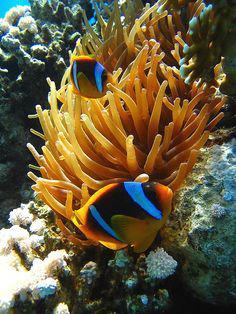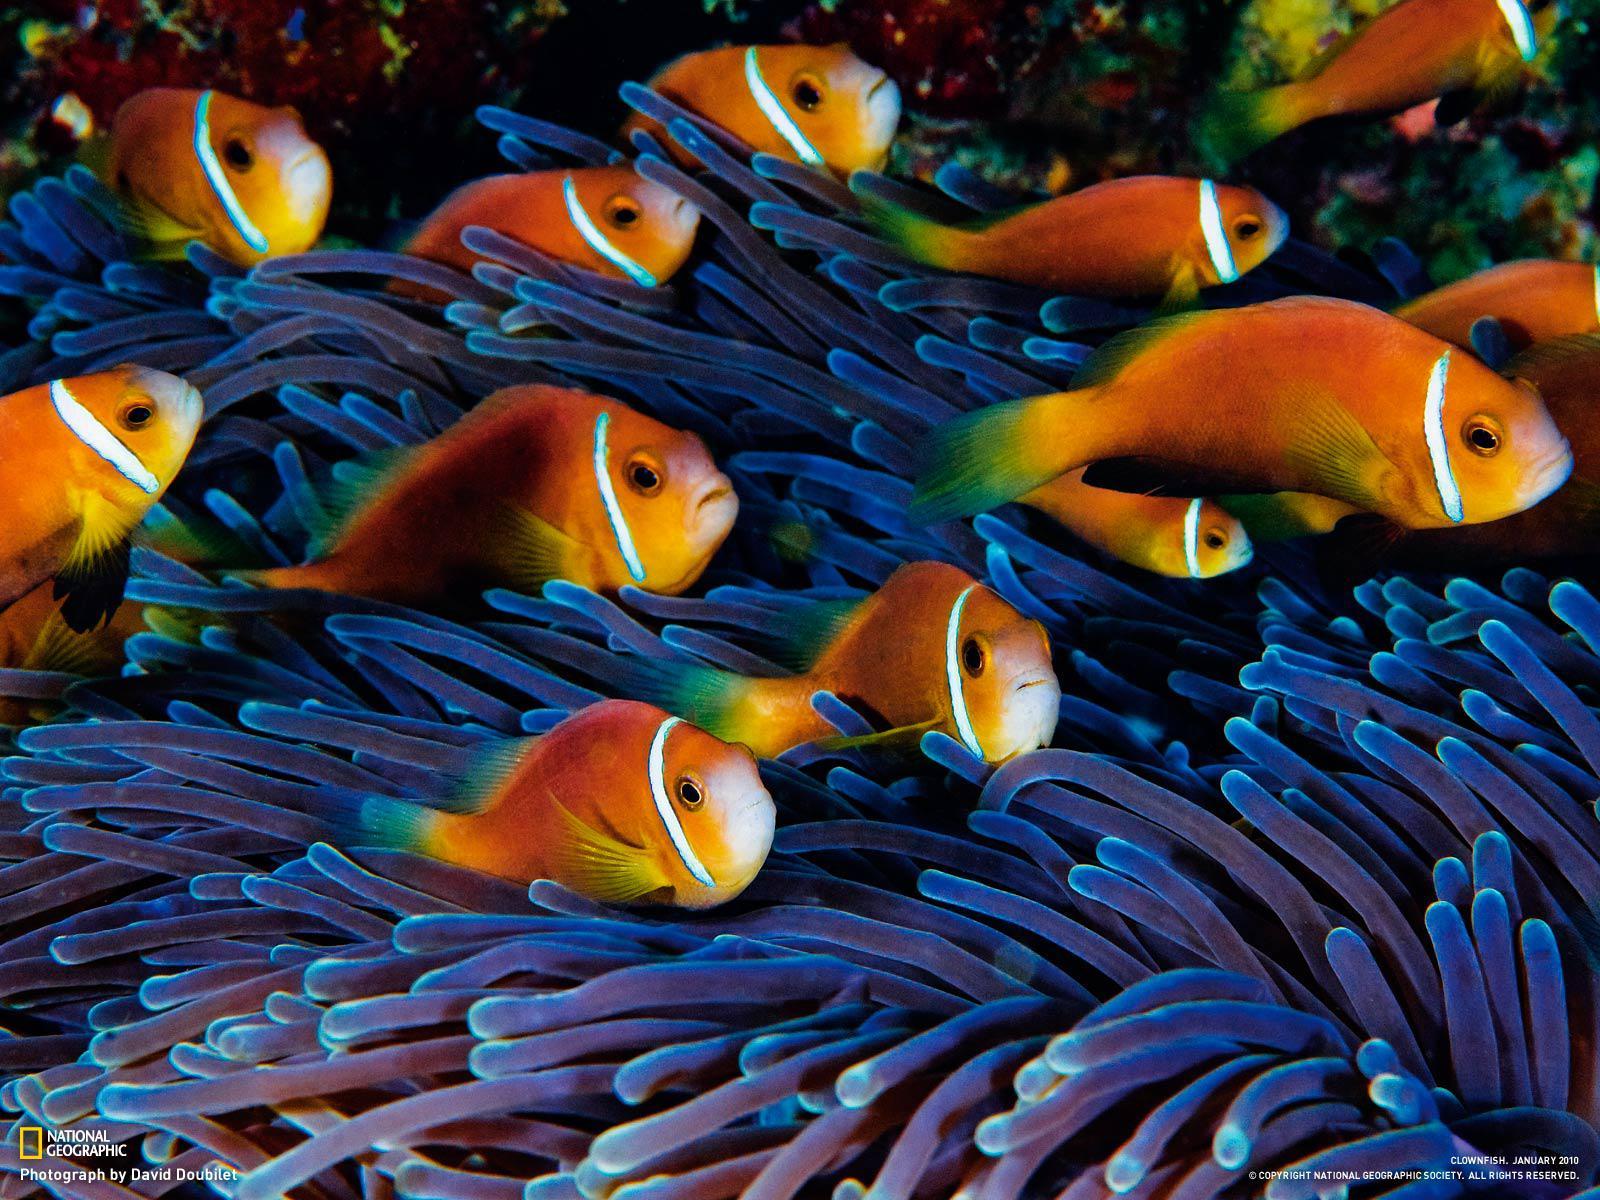The first image is the image on the left, the second image is the image on the right. Evaluate the accuracy of this statement regarding the images: "In one of the images there are at least three orange fish swimming around a large number of sea anemone.". Is it true? Answer yes or no. Yes. The first image is the image on the left, the second image is the image on the right. Given the left and right images, does the statement "One image shows exactly three orange-and-white clown fish swimming by an anemone." hold true? Answer yes or no. No. 